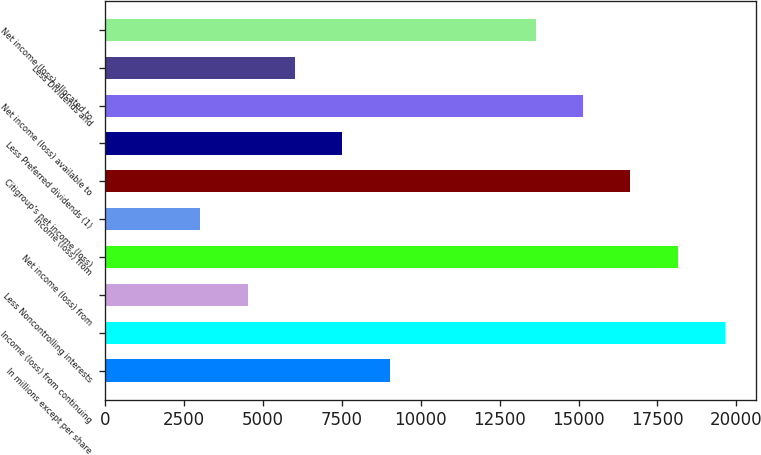Convert chart to OTSL. <chart><loc_0><loc_0><loc_500><loc_500><bar_chart><fcel>In millions except per share<fcel>Income (loss) from continuing<fcel>Less Noncontrolling interests<fcel>Net income (loss) from<fcel>Income (loss) from<fcel>Citigroup's net income (loss)<fcel>Less Preferred dividends (1)<fcel>Net income (loss) available to<fcel>Less Dividends and<fcel>Net income (loss) allocated to<nl><fcel>9021.7<fcel>19651.3<fcel>4513.21<fcel>18148.5<fcel>3010.38<fcel>16645.7<fcel>7518.87<fcel>15142.8<fcel>6016.04<fcel>13640<nl></chart> 